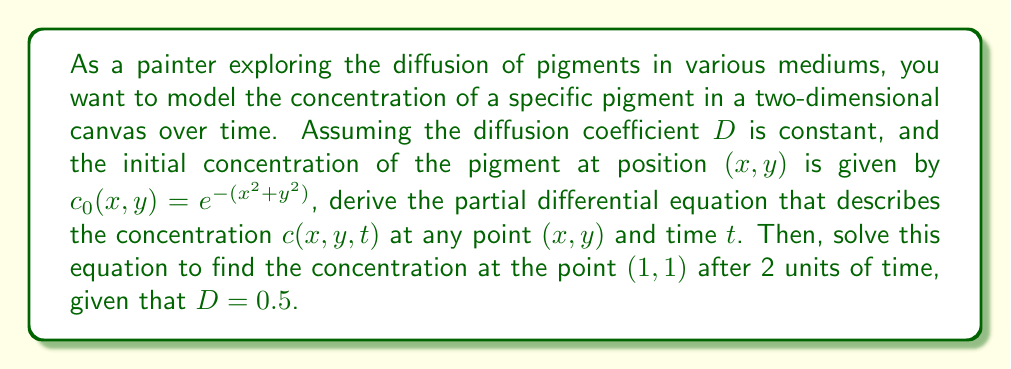Can you solve this math problem? 1. The diffusion of pigments in a two-dimensional medium is described by the 2D diffusion equation:

   $$\frac{\partial c}{\partial t} = D \left(\frac{\partial^2 c}{\partial x^2} + \frac{\partial^2 c}{\partial y^2}\right)$$

2. Given the initial condition $c_0(x,y) = e^{-(x^2+y^2)}$, we can solve this equation using the fundamental solution of the 2D diffusion equation:

   $$c(x,y,t) = \frac{1}{4\pi Dt} \int_{-\infty}^{\infty} \int_{-\infty}^{\infty} e^{-\frac{(x-x')^2+(y-y')^2}{4Dt}} c_0(x',y') dx'dy'$$

3. Substituting the initial condition:

   $$c(x,y,t) = \frac{1}{4\pi Dt} \int_{-\infty}^{\infty} \int_{-\infty}^{\infty} e^{-\frac{(x-x')^2+(y-y')^2}{4Dt}} e^{-(x'^2+y'^2)} dx'dy'$$

4. This integral can be evaluated analytically, resulting in:

   $$c(x,y,t) = \frac{1}{1+4Dt} e^{-\frac{x^2+y^2}{1+4Dt}}$$

5. Now, we need to find $c(1,1,2)$ with $D = 0.5$:

   $$c(1,1,2) = \frac{1}{1+4(0.5)(2)} e^{-\frac{1^2+1^2}{1+4(0.5)(2)}}$$

6. Simplifying:

   $$c(1,1,2) = \frac{1}{5} e^{-\frac{2}{5}} \approx 0.0902$$
Answer: $0.0902$ 